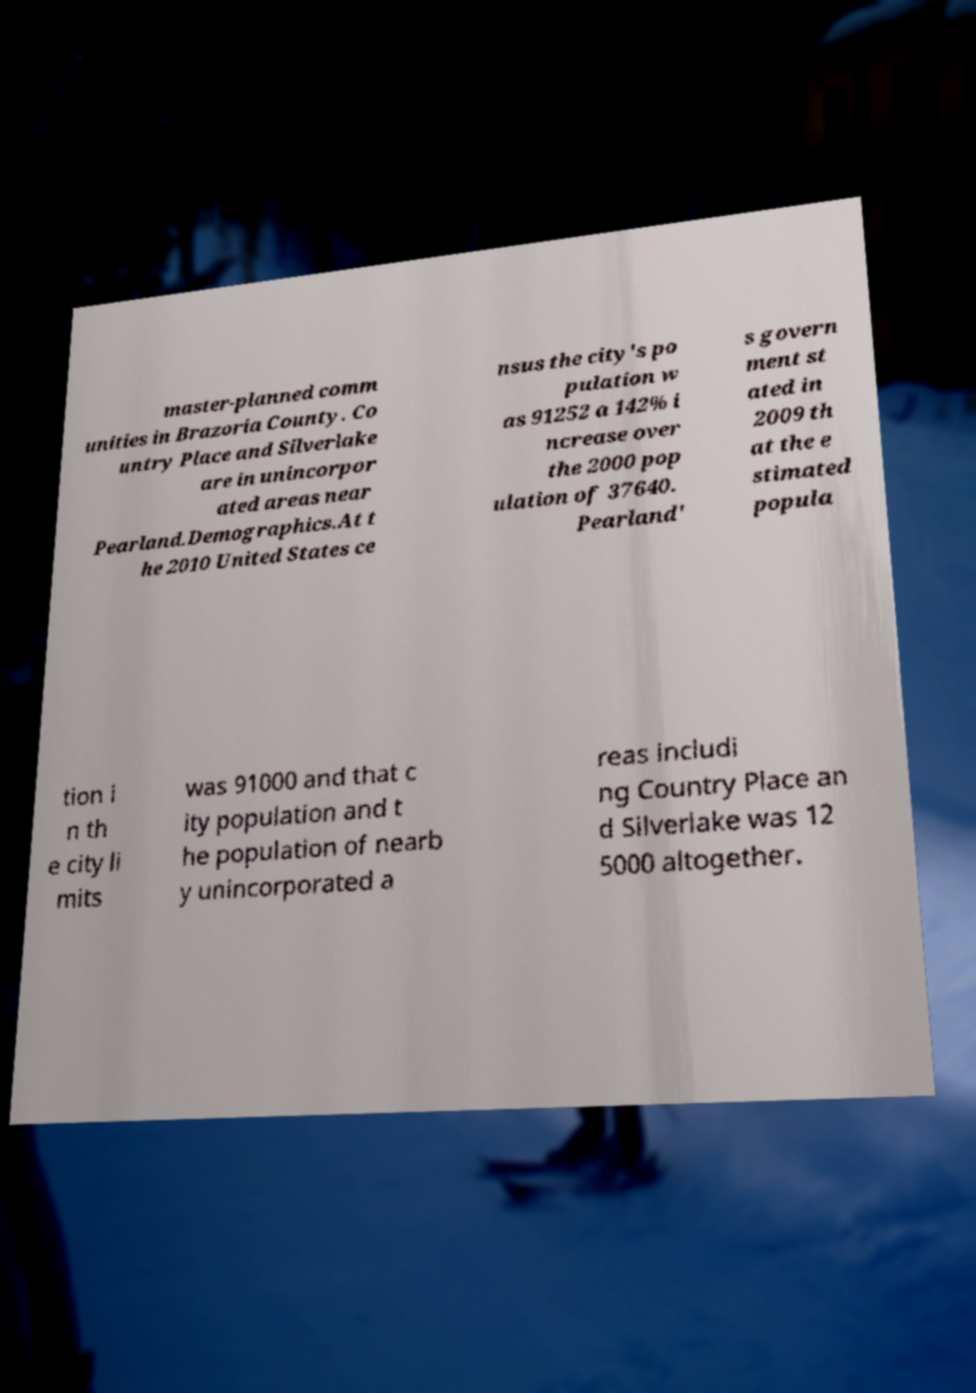What messages or text are displayed in this image? I need them in a readable, typed format. master-planned comm unities in Brazoria County. Co untry Place and Silverlake are in unincorpor ated areas near Pearland.Demographics.At t he 2010 United States ce nsus the city's po pulation w as 91252 a 142% i ncrease over the 2000 pop ulation of 37640. Pearland' s govern ment st ated in 2009 th at the e stimated popula tion i n th e city li mits was 91000 and that c ity population and t he population of nearb y unincorporated a reas includi ng Country Place an d Silverlake was 12 5000 altogether. 